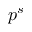<formula> <loc_0><loc_0><loc_500><loc_500>p ^ { s }</formula> 